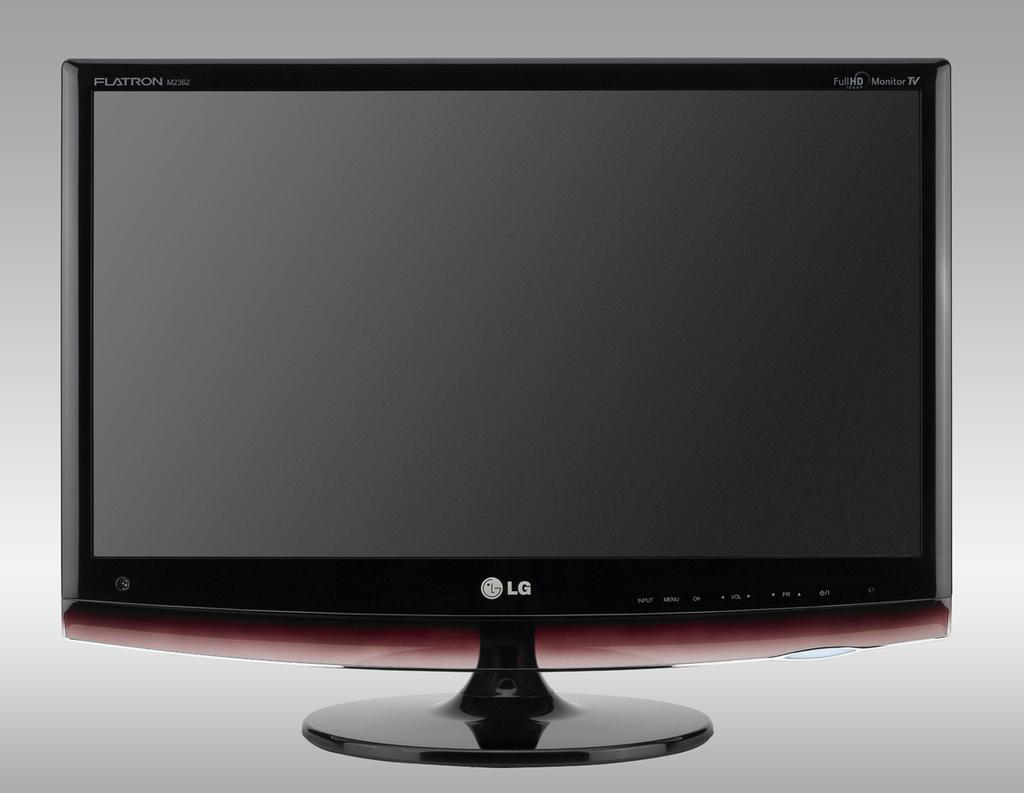What electronic device is present in the image? There is a television in the image. What can be seen on the television screen? There is text written in the top left and top right corners of the television screen, as well as a logo and text at the bottom of the screen. Can you tell me how many people are swimming in the image? There is no swimming or people swimming present in the image; it features a television with text and a logo on the screen. 